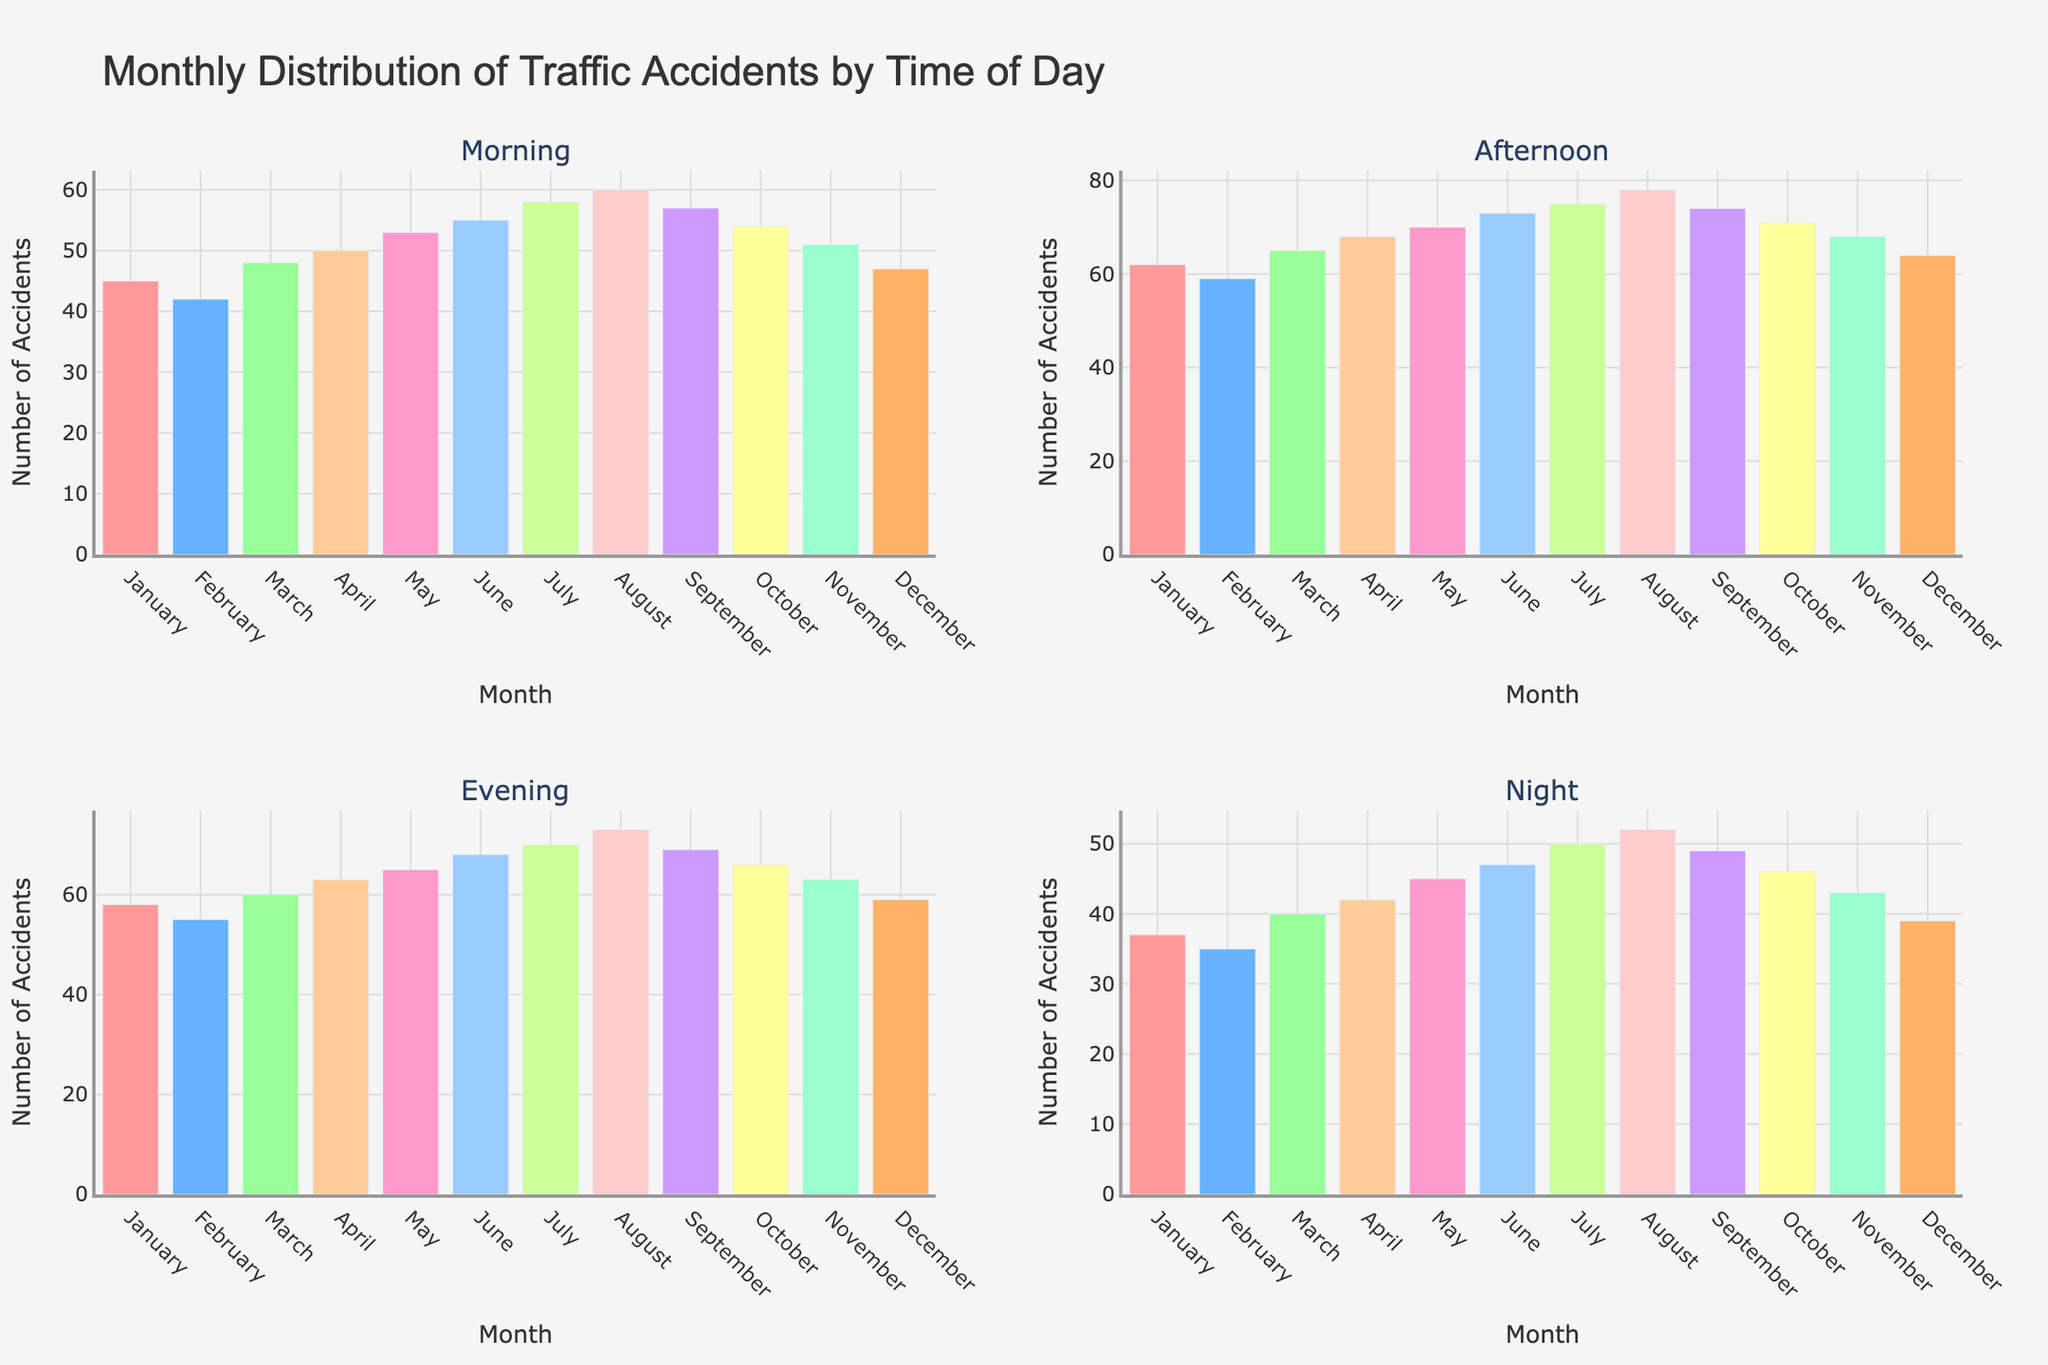What is the total number of accidents in January? Add the number of accidents in January for each time of day: 45 (Morning) + 62 (Afternoon) + 58 (Evening) + 37 (Night) = 202
Answer: 202 In which month and time of day did the highest number of accidents occur? Compare the number of accidents for all months and times of day. The highest number is in August Afternoon with 78 accidents.
Answer: August Afternoon How many more accidents happen in the Evening in July compared to January? Subtract the number of accidents in the Evening in January from those in July: 70 (July) − 58 (January) = 12 more accidents
Answer: 12 more accidents Which time of day has the most accidents on average across all months? To find the average number of accidents for each time of day, sum the accidents for all months at each time of day and divide by 12 (number of months). Calculate for each time: 
Morning: (45+42+48+50+53+55+58+60+57+54+51+47)/12 = 52.08 
Afternoon: (62+59+65+68+70+73+75+78+74+71+68+64)/12 = 68.25 
Evening: (58+55+60+63+65+68+70+73+69+66+63+59)/12 = 64.83 
Night: (37+35+40+42+45+47+50+52+49+46+43+39)/12 = 43.25 
Afternoon has the highest average with 68.25.
Answer: Afternoon Which month shows the least variance in the number of accidents throughout the day? Calculate the variance of the number of accidents for each month’s times of day. 
January: Variance of [45, 62, 58, 37] = ((45-50.5)² + (62-50.5)² + (58-50.5)² + (37-50.5)²)/4 = 106.25 
February: Variance of [42, 59, 55, 35] = 117.25 
March: Variance of [48, 65, 60, 40] = 108.25 
April: Variance of [50, 68, 63, 42] = 110.25 
May: Variance of [53, 70, 65, 45] = 104.25 
June: Variance of [55, 73, 68, 47] = 108.25 
July: Variance of [58, 75, 70, 50] = 104.25 
August: Variance of [60, 78, 73, 52] = 107.25 
September: Variance of [57, 74, 69, 49] = 102.25 
October: Variance of [54, 71, 66, 46] = 104.25 
November: Variance of [51, 68, 63, 43] = 104.25 
December: Variance of [47, 64, 59, 39] = 102.25
September and December have the lowest variance at 102.25.
Answer: September, December How does the number of accidents in the Afternoon in June compare to the Evening in the same month? Compare the numbers directly: June Afternoon (73) and June Evening (68). Subtract Evening from Afternoon = 5
Answer: 5 more accidents in the Afternoon What is the difference in the number of accidents between the Morning and Night in August? Subtract the number of accidents at Night from those in the Morning in August: 60 (Morning) − 52 (Night) = 8 fewer accidents
Answer: 8 more accidents in the Morning 